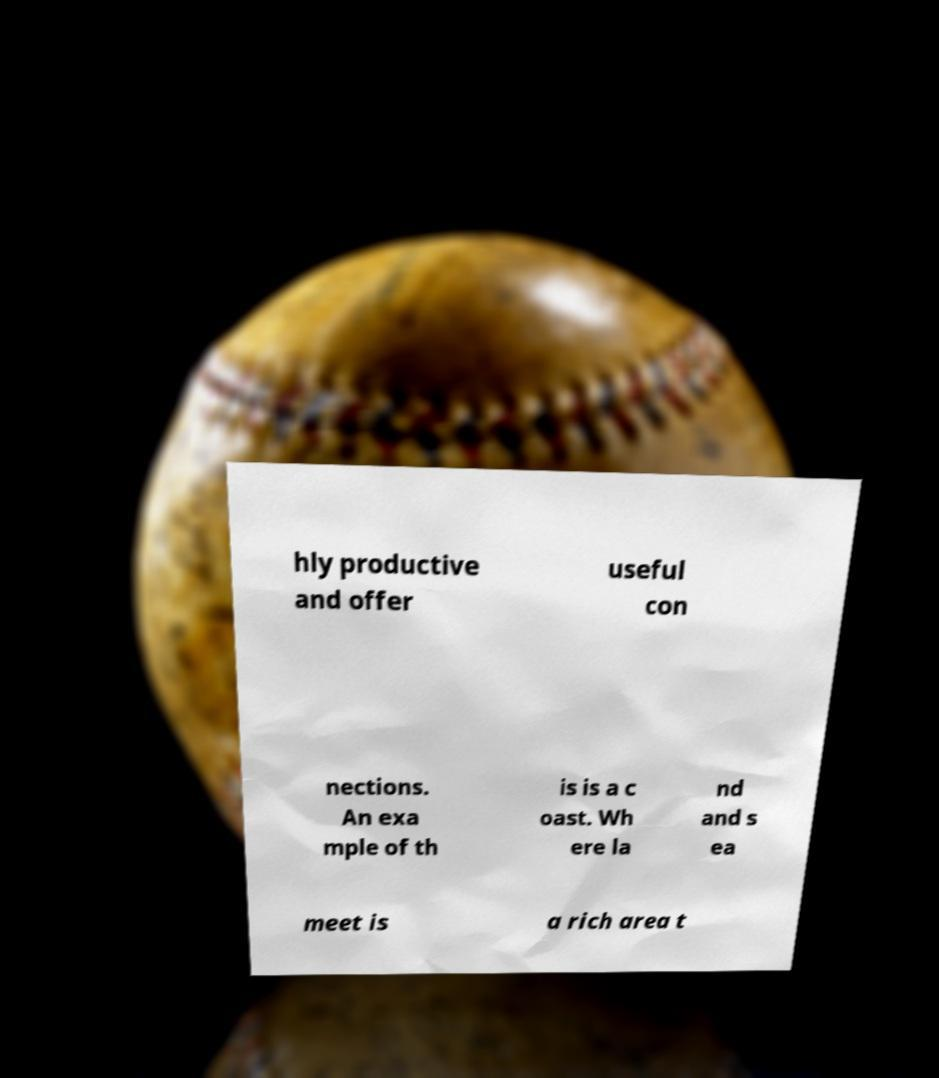Could you assist in decoding the text presented in this image and type it out clearly? hly productive and offer useful con nections. An exa mple of th is is a c oast. Wh ere la nd and s ea meet is a rich area t 